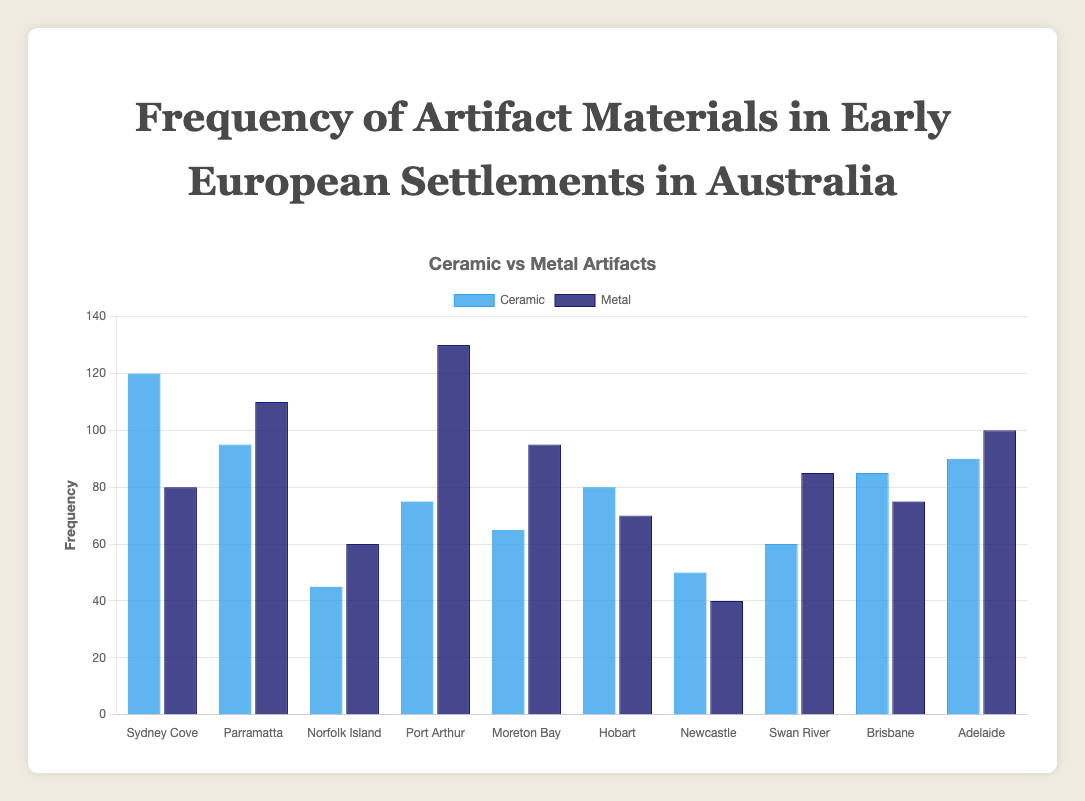What's the total number of ceramic artifacts found in all settlements? Add all the ceramic artifacts: 120 (Sydney Cove) + 95 (Parramatta) + 45 (Norfolk Island) + 75 (Port Arthur) + 65 (Moreton Bay) + 80 (Hobart) + 50 (Newcastle) + 60 (Swan River) + 85 (Brisbane) + 90 (Adelaide). The total is 765.
Answer: 765 Which settlement has the highest number of metal artifacts? Look at the height of the dark blue bars for all the settlements. The highest bar is for Port Arthur with 130 metal artifacts.
Answer: Port Arthur What's the difference in the number of ceramic artifacts between Sydney Cove and Swan River? Subtract the number of ceramic artifacts in Swan River from that in Sydney Cove: 120 (Sydney Cove) - 60 (Swan River) = 60.
Answer: 60 In which settlement is the ratio of ceramic to metal artifacts the highest? Calculate the ratio of ceramic to metal for each settlement and compare them: Sydney Cove (120/80 = 1.5), Parramatta (95/110 ≈ 0.86), Norfolk Island (45/60 = 0.75), Port Arthur (75/130 ≈ 0.58), Moreton Bay (65/95 ≈ 0.68), Hobart (80/70 ≈ 1.14), Newcastle (50/40 = 1.25), Swan River (60/85 ≈ 0.71), Brisbane (85/75 ≈ 1.13), Adelaide (90/100 = 0.9). The highest ratio is in Sydney Cove (1.5).
Answer: Sydney Cove Which settlements have a higher number of metal artifacts than ceramic artifacts? Compare the metal and ceramic artifact numbers in each settlement: Parramatta (110 > 95), Port Arthur (130 > 75), Moreton Bay (95 > 65), Swan River (85 > 60), Adelaide (100 > 90).
Answer: Parramatta, Port Arthur, Moreton Bay, Swan River, Adelaide Which settlement has the lowest total number of artifacts (ceramic + metal)? Add the ceramic and metal artifact numbers for each settlement and find the smallest sum: Sydney Cove (120 + 80 = 200), Parramatta (95 + 110 = 205), Norfolk Island (45 + 60 = 105), Port Arthur (75 + 130 = 205), Moreton Bay (65 + 95 = 160), Hobart (80 + 70 = 150), Newcastle (50 + 40 = 90), Swan River (60 + 85 = 145), Brisbane (85 + 75 = 160), Adelaide (90 + 100 = 190). The smallest total is in Newcastle (90).
Answer: Newcastle How many settlements have at least twice as many ceramic artifacts as metal artifacts? Check for each settlement where ceramic artifacts are at least double the metal artifacts: Sydney Cove (120 >= 2 * 80, False), Parramatta (95 >= 2 * 110, False), Norfolk Island (45 >= 2 * 60, False), Port Arthur (75 >= 2 * 130, False), Moreton Bay (65 >= 2 * 95, False), Hobart (80 >= 2 * 70, False), Newcastle (50 >= 2 * 40, False), Swan River (60 >= 2 * 85, False), Brisbane (85 >= 2 * 75, False), Adelaide (90 >= 2 * 100, False). None of the settlements meet this criterion.
Answer: None What is the average number of metal artifacts found in the settlements? Add all the metal artifacts and divide by the number of settlements: (80 + 110 + 60 + 130 + 95 + 70 + 40 + 85 + 75 + 100) / 10 = 845 / 10 = 84.5.
Answer: 84.5 